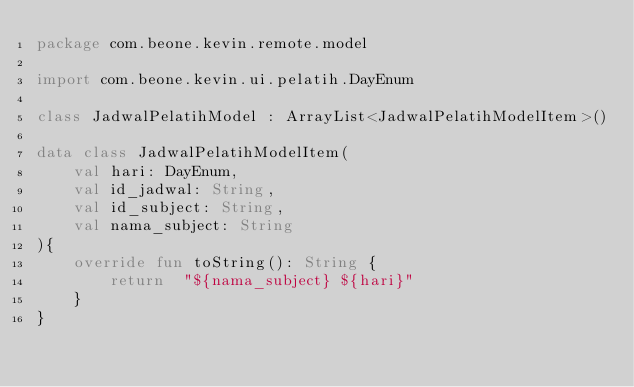Convert code to text. <code><loc_0><loc_0><loc_500><loc_500><_Kotlin_>package com.beone.kevin.remote.model

import com.beone.kevin.ui.pelatih.DayEnum

class JadwalPelatihModel : ArrayList<JadwalPelatihModelItem>()

data class JadwalPelatihModelItem(
    val hari: DayEnum,
    val id_jadwal: String,
    val id_subject: String,
    val nama_subject: String
){
    override fun toString(): String {
        return  "${nama_subject} ${hari}"
    }
}</code> 